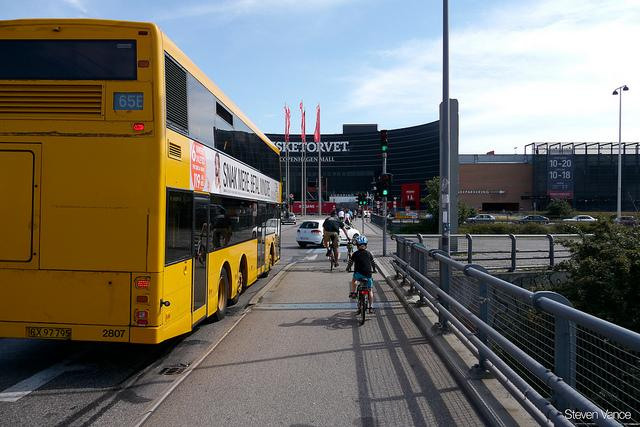What is the full name of the building ahead? Please explain your reasoning. fisketorvet. There is an "i" partially visible before the "s". answer a is the only option with this combination. 